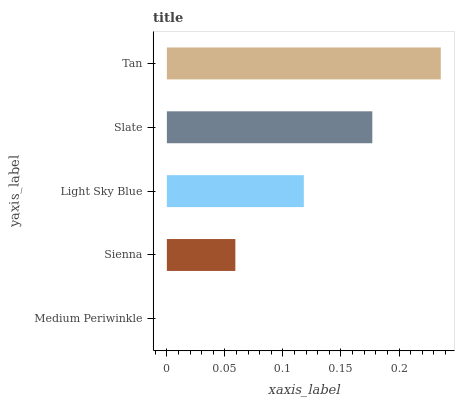Is Medium Periwinkle the minimum?
Answer yes or no. Yes. Is Tan the maximum?
Answer yes or no. Yes. Is Sienna the minimum?
Answer yes or no. No. Is Sienna the maximum?
Answer yes or no. No. Is Sienna greater than Medium Periwinkle?
Answer yes or no. Yes. Is Medium Periwinkle less than Sienna?
Answer yes or no. Yes. Is Medium Periwinkle greater than Sienna?
Answer yes or no. No. Is Sienna less than Medium Periwinkle?
Answer yes or no. No. Is Light Sky Blue the high median?
Answer yes or no. Yes. Is Light Sky Blue the low median?
Answer yes or no. Yes. Is Slate the high median?
Answer yes or no. No. Is Medium Periwinkle the low median?
Answer yes or no. No. 